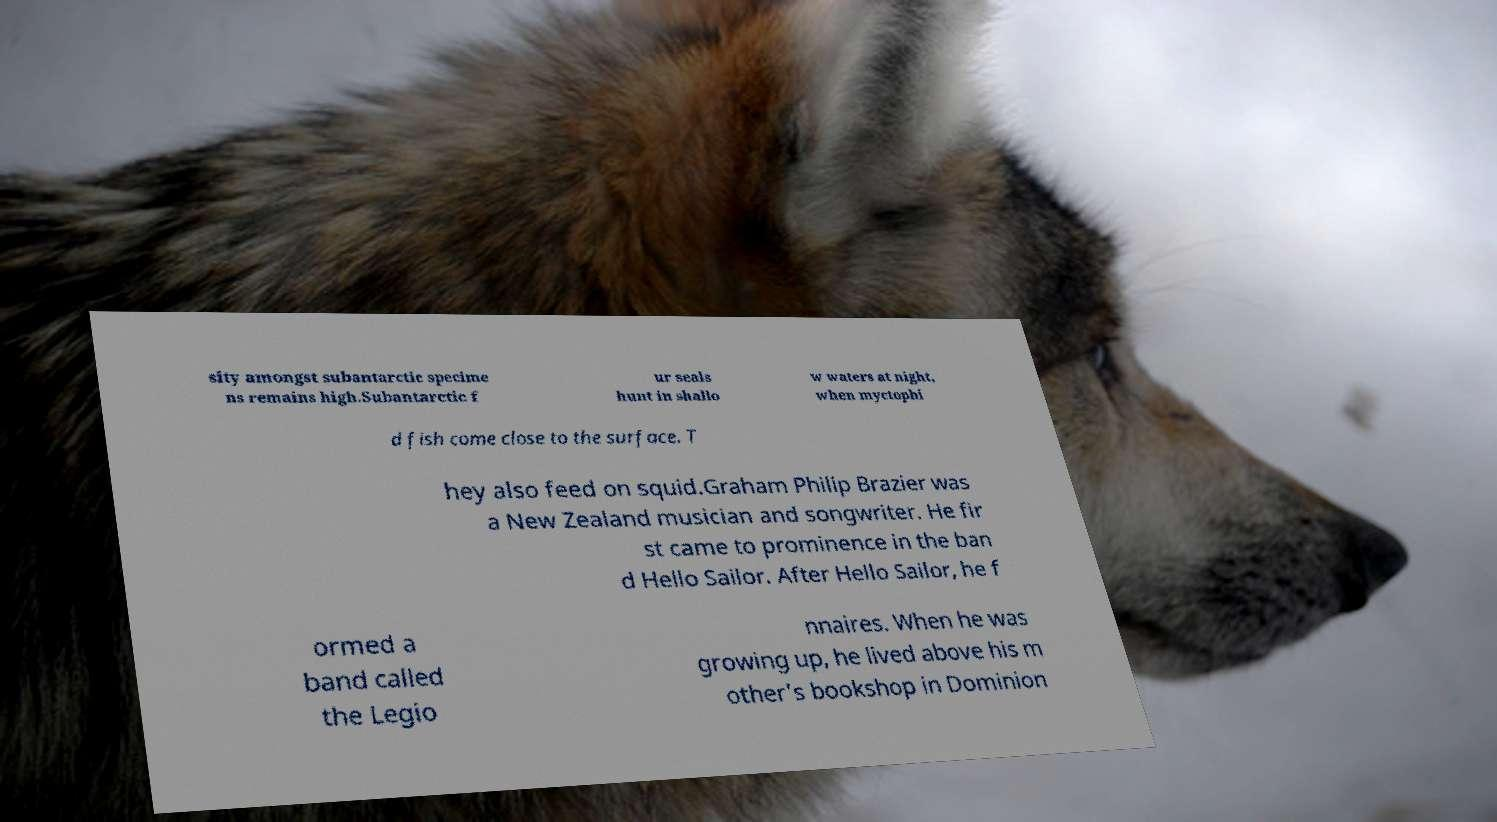Could you assist in decoding the text presented in this image and type it out clearly? sity amongst subantarctic specime ns remains high.Subantarctic f ur seals hunt in shallo w waters at night, when myctophi d fish come close to the surface. T hey also feed on squid.Graham Philip Brazier was a New Zealand musician and songwriter. He fir st came to prominence in the ban d Hello Sailor. After Hello Sailor, he f ormed a band called the Legio nnaires. When he was growing up, he lived above his m other's bookshop in Dominion 